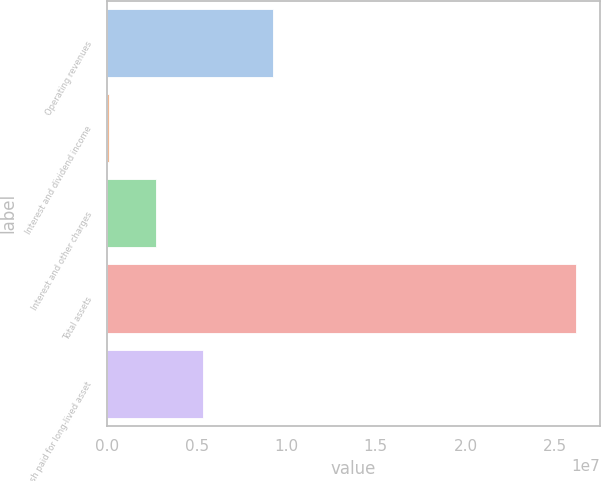Convert chart to OTSL. <chart><loc_0><loc_0><loc_500><loc_500><bar_chart><fcel>Operating revenues<fcel>Interest and dividend income<fcel>Interest and other charges<fcel>Total assets<fcel>Cash paid for long-lived asset<nl><fcel>9.25508e+06<fcel>124992<fcel>2.72991e+06<fcel>2.61742e+07<fcel>5.33483e+06<nl></chart> 